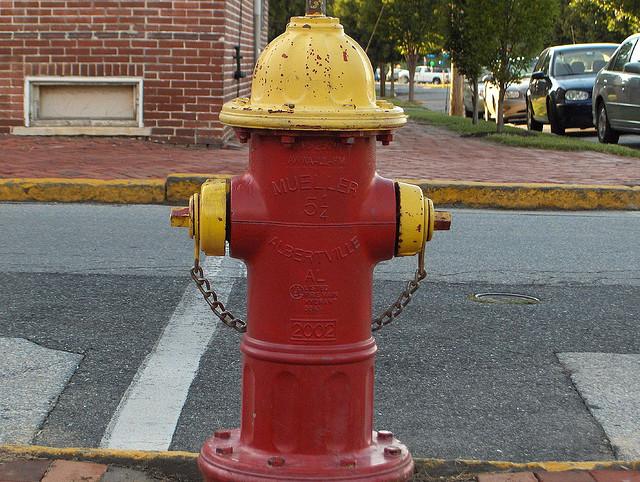Is the hydrant red?
Keep it brief. Yes. Is there anything at all out of the ordinary in this scene?
Give a very brief answer. No. What are the chains for?
Answer briefly. Lock. Is there a face on the hydrant?
Be succinct. No. Is there a stripe on the street?
Be succinct. Yes. How many colors is the fire hydrant?
Answer briefly. 2. Which one is the hydrant?
Short answer required. Middle. How many cars are in the background?
Quick response, please. 5. Is that a real fire hydrant?
Keep it brief. Yes. 